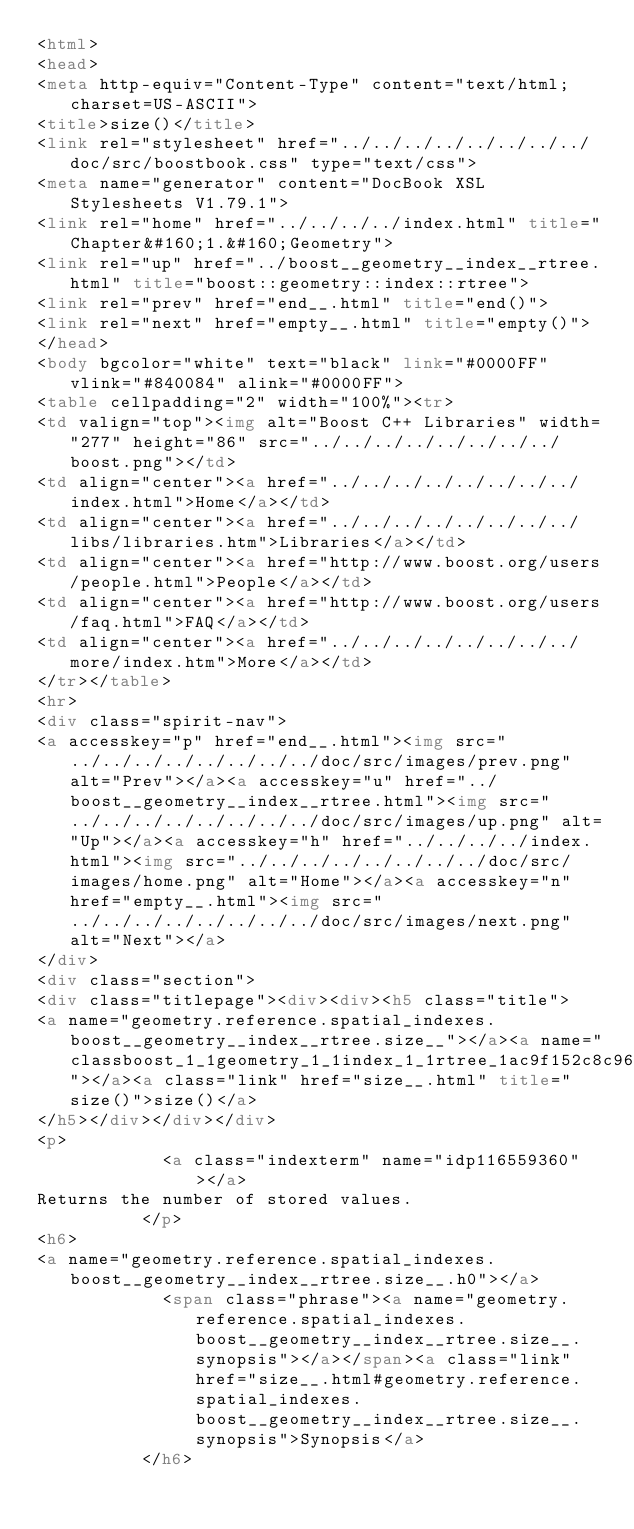Convert code to text. <code><loc_0><loc_0><loc_500><loc_500><_HTML_><html>
<head>
<meta http-equiv="Content-Type" content="text/html; charset=US-ASCII">
<title>size()</title>
<link rel="stylesheet" href="../../../../../../../../doc/src/boostbook.css" type="text/css">
<meta name="generator" content="DocBook XSL Stylesheets V1.79.1">
<link rel="home" href="../../../../index.html" title="Chapter&#160;1.&#160;Geometry">
<link rel="up" href="../boost__geometry__index__rtree.html" title="boost::geometry::index::rtree">
<link rel="prev" href="end__.html" title="end()">
<link rel="next" href="empty__.html" title="empty()">
</head>
<body bgcolor="white" text="black" link="#0000FF" vlink="#840084" alink="#0000FF">
<table cellpadding="2" width="100%"><tr>
<td valign="top"><img alt="Boost C++ Libraries" width="277" height="86" src="../../../../../../../../boost.png"></td>
<td align="center"><a href="../../../../../../../../index.html">Home</a></td>
<td align="center"><a href="../../../../../../../../libs/libraries.htm">Libraries</a></td>
<td align="center"><a href="http://www.boost.org/users/people.html">People</a></td>
<td align="center"><a href="http://www.boost.org/users/faq.html">FAQ</a></td>
<td align="center"><a href="../../../../../../../../more/index.htm">More</a></td>
</tr></table>
<hr>
<div class="spirit-nav">
<a accesskey="p" href="end__.html"><img src="../../../../../../../../doc/src/images/prev.png" alt="Prev"></a><a accesskey="u" href="../boost__geometry__index__rtree.html"><img src="../../../../../../../../doc/src/images/up.png" alt="Up"></a><a accesskey="h" href="../../../../index.html"><img src="../../../../../../../../doc/src/images/home.png" alt="Home"></a><a accesskey="n" href="empty__.html"><img src="../../../../../../../../doc/src/images/next.png" alt="Next"></a>
</div>
<div class="section">
<div class="titlepage"><div><div><h5 class="title">
<a name="geometry.reference.spatial_indexes.boost__geometry__index__rtree.size__"></a><a name="classboost_1_1geometry_1_1index_1_1rtree_1ac9f152c8c96525e3735b81635d8171b1"></a><a class="link" href="size__.html" title="size()">size()</a>
</h5></div></div></div>
<p>
            <a class="indexterm" name="idp116559360"></a>
Returns the number of stored values.
          </p>
<h6>
<a name="geometry.reference.spatial_indexes.boost__geometry__index__rtree.size__.h0"></a>
            <span class="phrase"><a name="geometry.reference.spatial_indexes.boost__geometry__index__rtree.size__.synopsis"></a></span><a class="link" href="size__.html#geometry.reference.spatial_indexes.boost__geometry__index__rtree.size__.synopsis">Synopsis</a>
          </h6></code> 